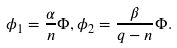Convert formula to latex. <formula><loc_0><loc_0><loc_500><loc_500>\phi _ { 1 } = \frac { \alpha } { n } \Phi , \phi _ { 2 } = \frac { \beta } { q - n } \Phi .</formula> 